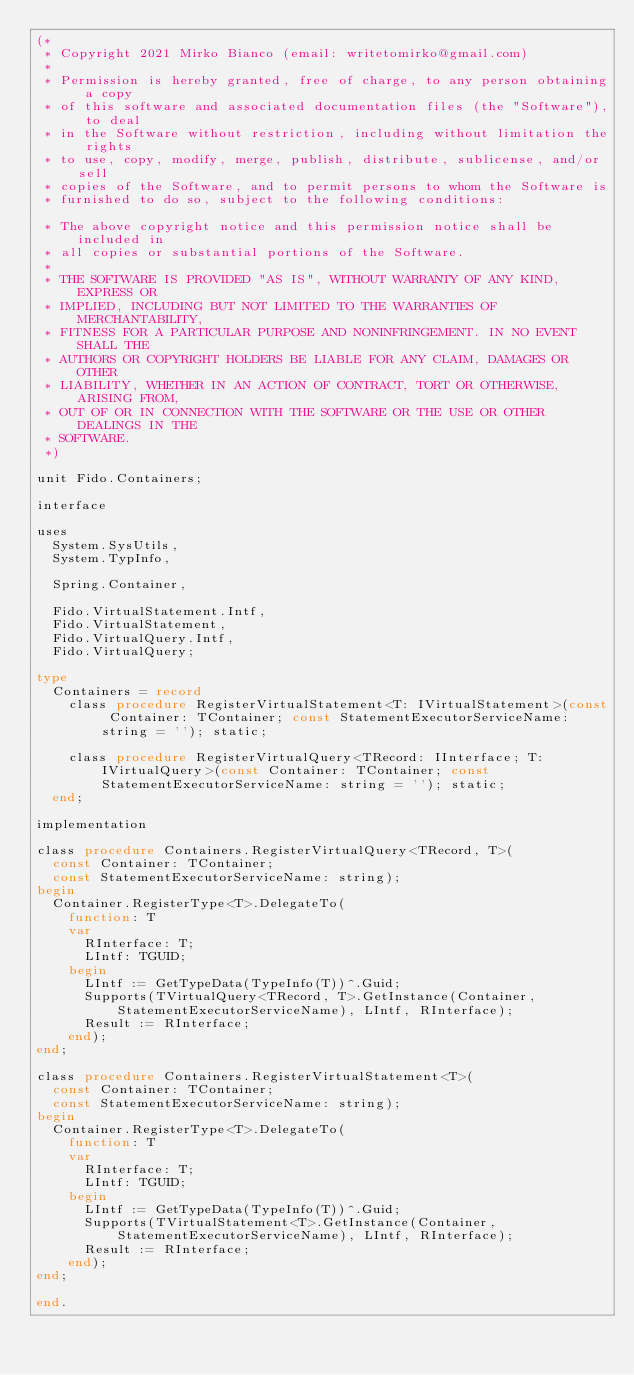Convert code to text. <code><loc_0><loc_0><loc_500><loc_500><_Pascal_>(*
 * Copyright 2021 Mirko Bianco (email: writetomirko@gmail.com)
 *
 * Permission is hereby granted, free of charge, to any person obtaining a copy
 * of this software and associated documentation files (the "Software"), to deal
 * in the Software without restriction, including without limitation the rights
 * to use, copy, modify, merge, publish, distribute, sublicense, and/or sell
 * copies of the Software, and to permit persons to whom the Software is
 * furnished to do so, subject to the following conditions:

 * The above copyright notice and this permission notice shall be included in
 * all copies or substantial portions of the Software.
 *
 * THE SOFTWARE IS PROVIDED "AS IS", WITHOUT WARRANTY OF ANY KIND, EXPRESS OR
 * IMPLIED, INCLUDING BUT NOT LIMITED TO THE WARRANTIES OF MERCHANTABILITY,
 * FITNESS FOR A PARTICULAR PURPOSE AND NONINFRINGEMENT. IN NO EVENT SHALL THE
 * AUTHORS OR COPYRIGHT HOLDERS BE LIABLE FOR ANY CLAIM, DAMAGES OR OTHER
 * LIABILITY, WHETHER IN AN ACTION OF CONTRACT, TORT OR OTHERWISE, ARISING FROM,
 * OUT OF OR IN CONNECTION WITH THE SOFTWARE OR THE USE OR OTHER DEALINGS IN THE
 * SOFTWARE.
 *)

unit Fido.Containers;

interface

uses
  System.SysUtils,
  System.TypInfo,

  Spring.Container,

  Fido.VirtualStatement.Intf,
  Fido.VirtualStatement,
  Fido.VirtualQuery.Intf,
  Fido.VirtualQuery;

type
  Containers = record
    class procedure RegisterVirtualStatement<T: IVirtualStatement>(const Container: TContainer; const StatementExecutorServiceName: string = ''); static;

    class procedure RegisterVirtualQuery<TRecord: IInterface; T: IVirtualQuery>(const Container: TContainer; const StatementExecutorServiceName: string = ''); static;
  end;

implementation

class procedure Containers.RegisterVirtualQuery<TRecord, T>(
  const Container: TContainer;
  const StatementExecutorServiceName: string);
begin
  Container.RegisterType<T>.DelegateTo(
    function: T
    var
      RInterface: T;
      LIntf: TGUID;
    begin
      LIntf := GetTypeData(TypeInfo(T))^.Guid;
      Supports(TVirtualQuery<TRecord, T>.GetInstance(Container, StatementExecutorServiceName), LIntf, RInterface);
      Result := RInterface;
    end);
end;

class procedure Containers.RegisterVirtualStatement<T>(
  const Container: TContainer;
  const StatementExecutorServiceName: string);
begin
  Container.RegisterType<T>.DelegateTo(
    function: T
    var
      RInterface: T;
      LIntf: TGUID;
    begin
      LIntf := GetTypeData(TypeInfo(T))^.Guid;
      Supports(TVirtualStatement<T>.GetInstance(Container, StatementExecutorServiceName), LIntf, RInterface);
      Result := RInterface;
    end);
end;

end.
</code> 